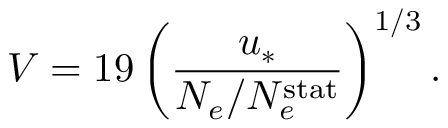<formula> <loc_0><loc_0><loc_500><loc_500>V = 1 9 \left ( \frac { u _ { \ast } } { N _ { e } / N _ { e } ^ { s t a t } } \right ) ^ { 1 / 3 } .</formula> 